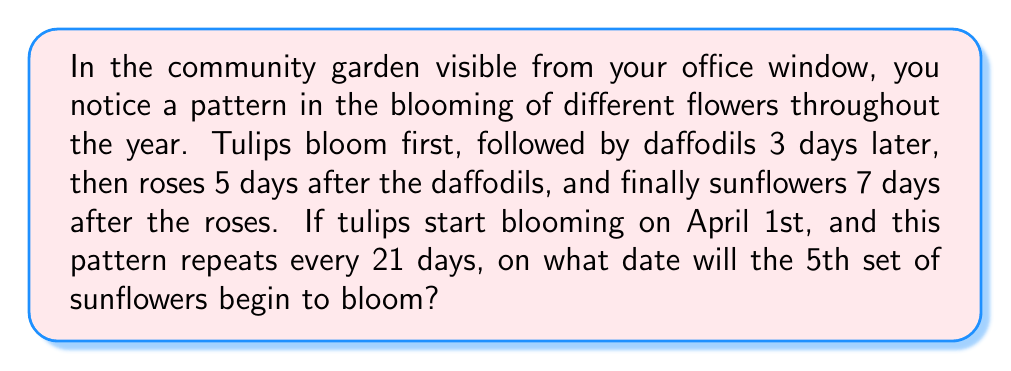Can you solve this math problem? Let's break this down step-by-step:

1) First, let's establish the blooming sequence within one cycle:
   - Day 1: Tulips
   - Day 4: Daffodils (1 + 3)
   - Day 9: Roses (4 + 5)
   - Day 16: Sunflowers (9 + 7)

2) The cycle repeats every 21 days. To find the 5th set of sunflowers, we need to calculate:
   $$(5 - 1) \times 21 + 16 = 4 \times 21 + 16 = 84 + 16 = 100$$

   This means the 5th set of sunflowers will bloom on the 100th day from April 1st.

3) To convert this to a date, we need to count 100 days from April 1st:
   - April has 30 days
   - May has 31 days
   - June has 30 days
   - July has 31 days

4) Let's count:
   - 30 days of April
   - 31 days of May (61 total)
   - 30 days of June (91 total)
   - We need 9 more days in July (100 total)

5) Therefore, the 100th day falls on July 9th.
Answer: July 9th 